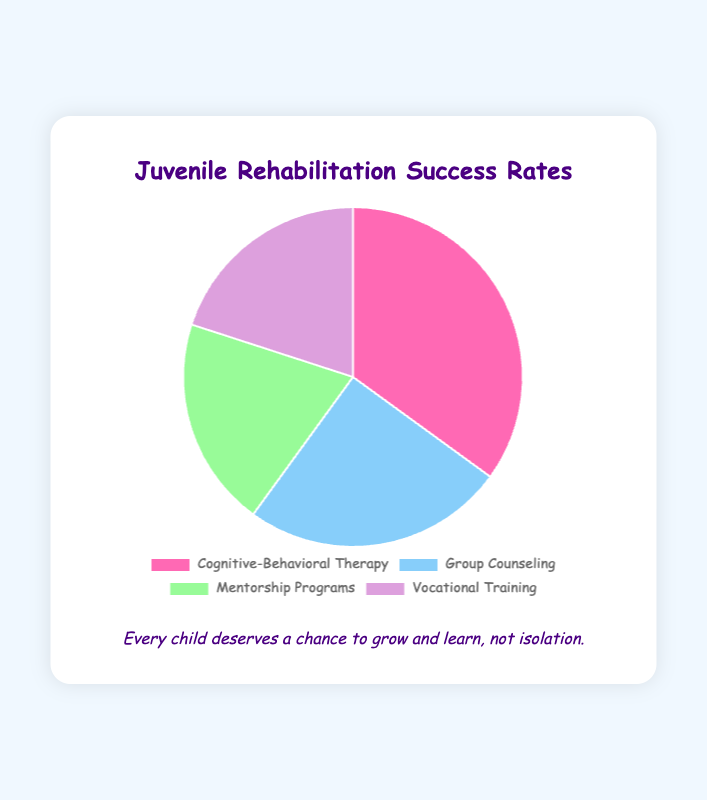What percentage of the rehabilitation success rates is attributed to Cognitive-Behavioral Therapy? The figure shows that Cognitive-Behavioral Therapy represents 35% of the rehabilitation success rates.
Answer: 35% Which rehabilitation method has the lowest success rate? Both Mentorship Programs and Vocational Training have the lowest success rate in the figure, each accounting for 20%.
Answer: Mentorship Programs and Vocational Training How much more successful is Cognitive-Behavioral Therapy compared to Group Counseling? Cognitive-Behavioral Therapy has a success rate of 35%, and Group Counseling has a success rate of 25%. The difference is 35% - 25% = 10%.
Answer: 10% What is the combined success rate of Mentorship Programs and Vocational Training? Both Mentorship Programs and Vocational Training have success rates of 20%. Combined, their success rates are 20% + 20% = 40%.
Answer: 40% What proportion of the success rate pie chart is represented by Cognitive-Behavioral Therapy and Group Counseling together? Cognitive-Behavioral Therapy contributes 35%, and Group Counseling contributes 25% to the success rates. Combined, they represent 35% + 25% = 60% of the pie chart.
Answer: 60% Which segment in the chart represents the highest rehabilitation success rate and what color is it? The highest rehabilitation success rate is attributed to Cognitive-Behavioral Therapy, which is represented by the pink segment in the chart.
Answer: Cognitive-Behavioral Therapy; pink Are there any two rehabilitation methods that have an equal success rate? The chart shows that Mentorship Programs and Vocational Training both have a success rate of 20%, making them equal.
Answer: Yes If the success rate percentages are aggregated into three categories: Cognitive-Behavioral Therapy, Group Counseling, and a combined category for Mentorship Programs and Vocational Training, what is the success rate for the new combined category? Mentorship Programs and Vocational Training each hold 20%, so their combined success rate is 20% + 20% = 40%.
Answer: 40% Compare the total success rates of Cognitive-Behavioral Therapy and Group Counseling to that of the remaining methods. Which is higher? Cognitive-Behavioral Therapy and Group Counseling together have a combined success rate of 60% (35% + 25%). The remaining methods, Mentorship Programs and Vocational Training together, contribute 40% (20% + 20%). The combined success rate of Cognitive-Behavioral Therapy and Group Counseling is higher.
Answer: Cognitive-Behavioral Therapy and Group Counseling What is the average success rate of all four rehabilitation methods? To find the average success rate, sum all percentages and divide by the number of methods: (35% + 25% + 20% + 20%) / 4 = 100% / 4 = 25%.
Answer: 25% 